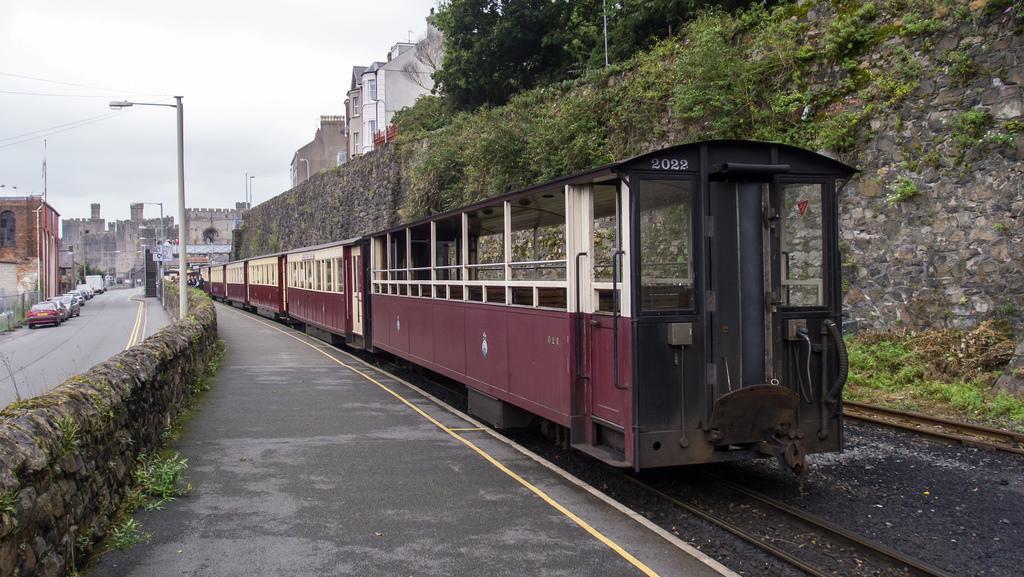Describe this image in one or two sentences. In the picture I can see a train on the track and it is on the right side. I can see the fence wall on the left side. I can see the vehicles on the side of the road. In the background, I can see the buildings and I can see the light poles on the side of the road. There are trees at the top of the image. There are clouds in the sky. 